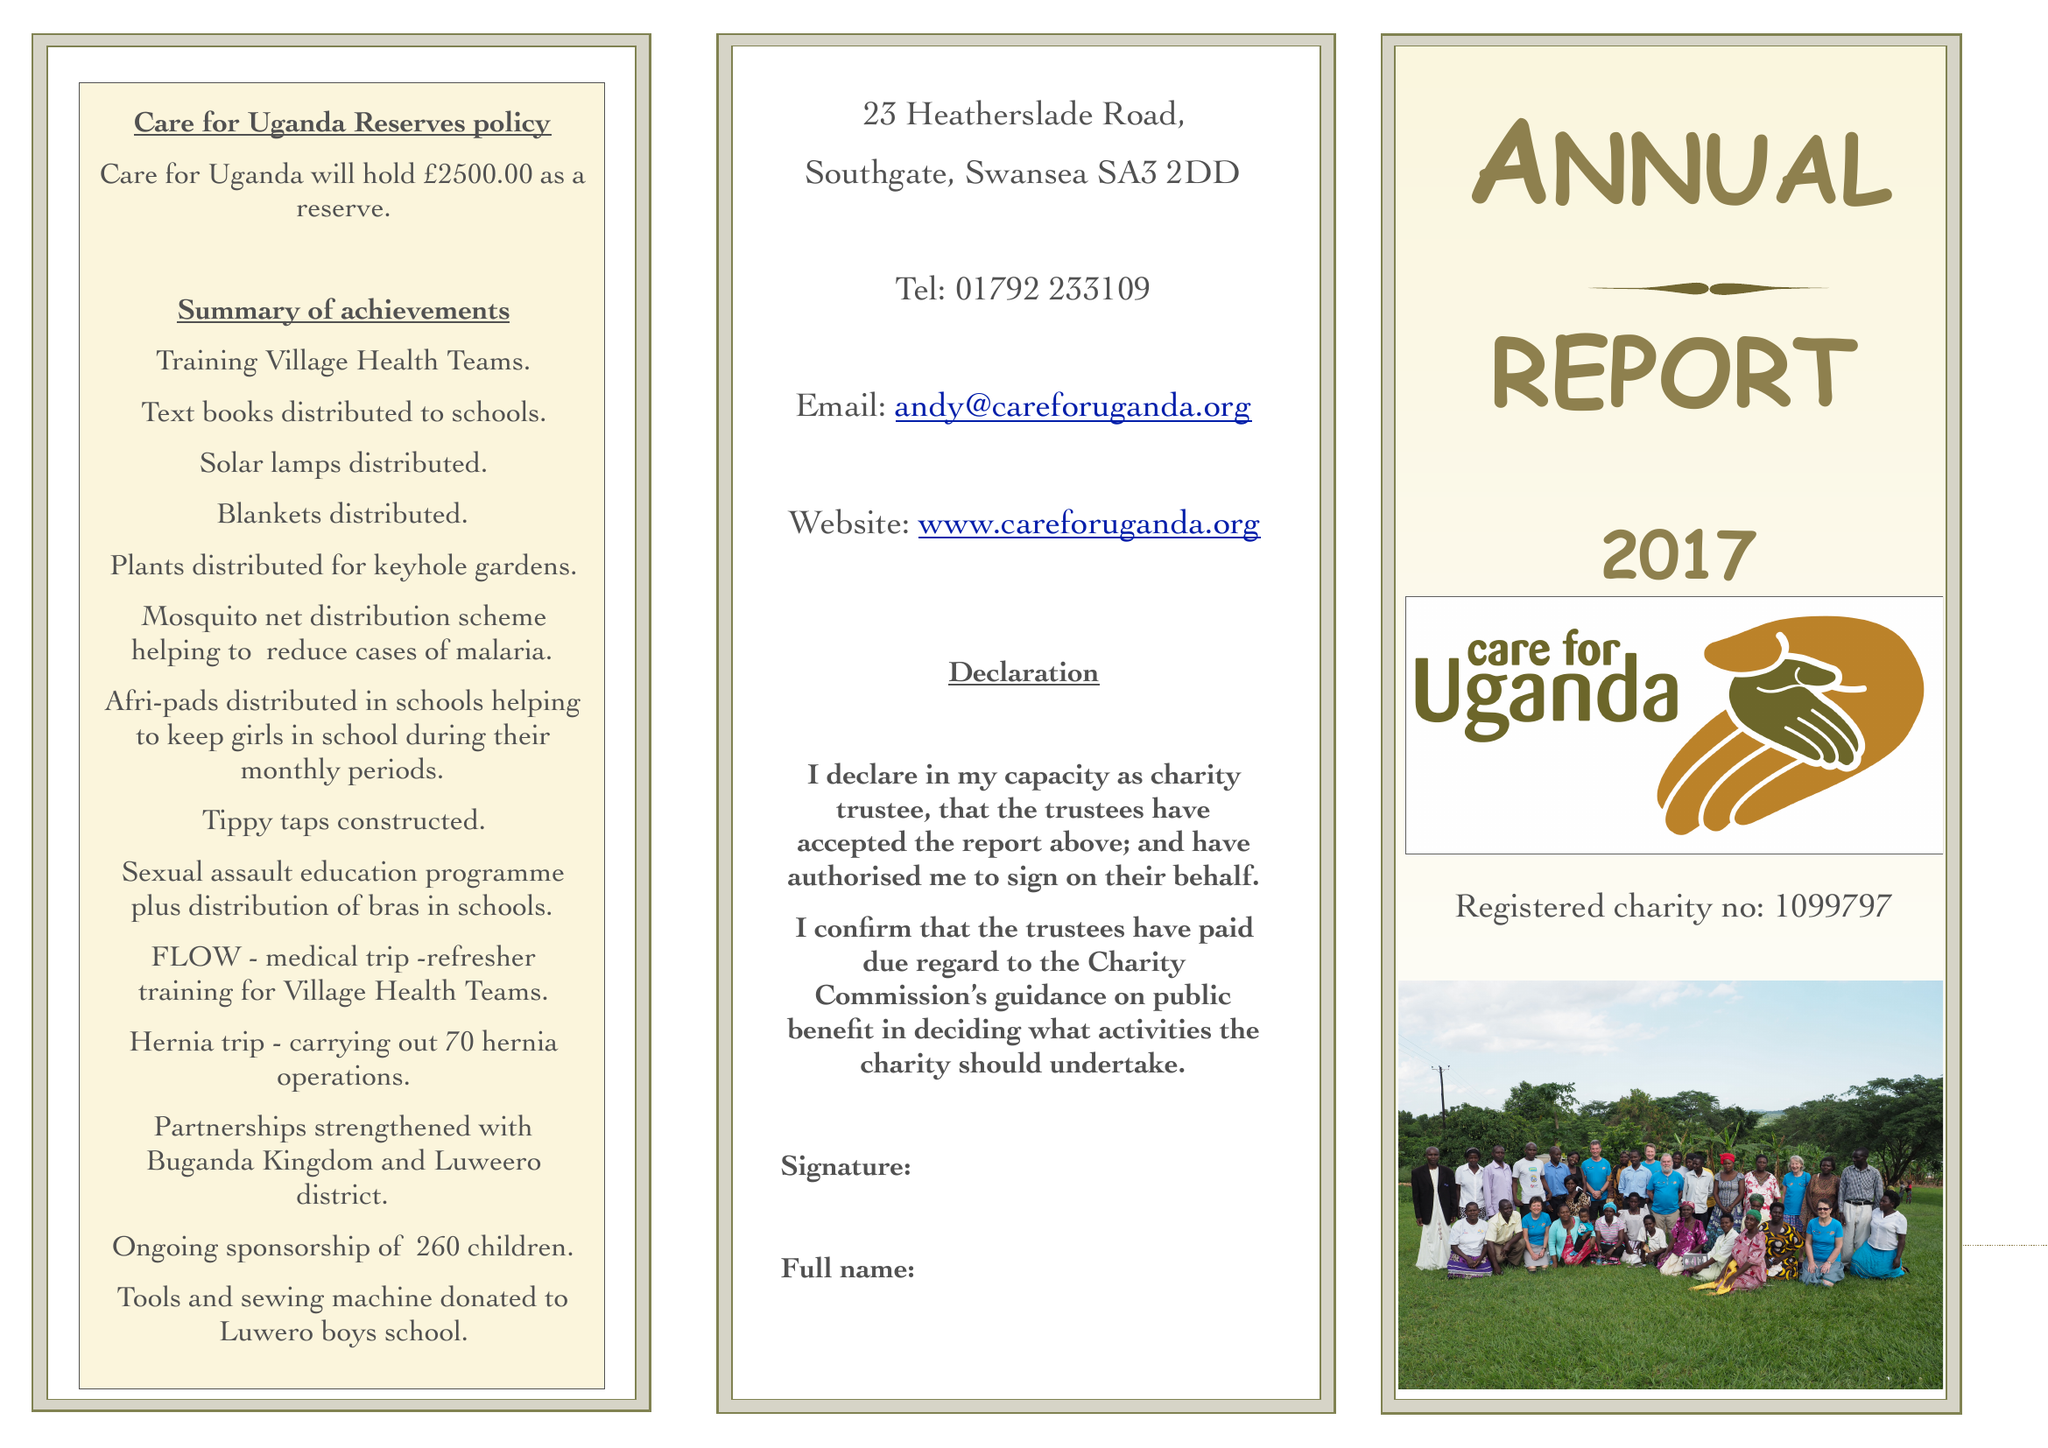What is the value for the charity_name?
Answer the question using a single word or phrase. Care For Uganda 